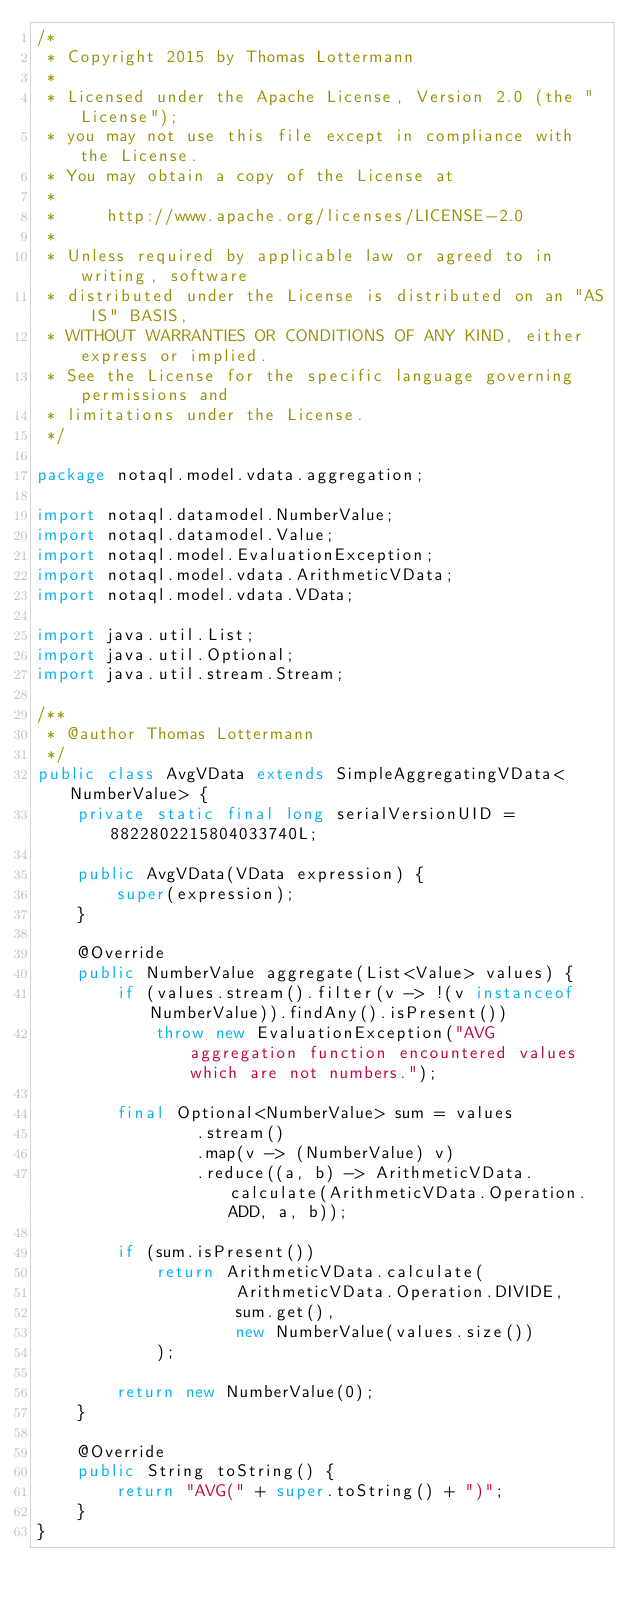<code> <loc_0><loc_0><loc_500><loc_500><_Java_>/*
 * Copyright 2015 by Thomas Lottermann
 *
 * Licensed under the Apache License, Version 2.0 (the "License");
 * you may not use this file except in compliance with the License.
 * You may obtain a copy of the License at
 *
 *     http://www.apache.org/licenses/LICENSE-2.0
 *
 * Unless required by applicable law or agreed to in writing, software
 * distributed under the License is distributed on an "AS IS" BASIS,
 * WITHOUT WARRANTIES OR CONDITIONS OF ANY KIND, either express or implied.
 * See the License for the specific language governing permissions and
 * limitations under the License.
 */

package notaql.model.vdata.aggregation;

import notaql.datamodel.NumberValue;
import notaql.datamodel.Value;
import notaql.model.EvaluationException;
import notaql.model.vdata.ArithmeticVData;
import notaql.model.vdata.VData;

import java.util.List;
import java.util.Optional;
import java.util.stream.Stream;

/**
 * @author Thomas Lottermann
 */
public class AvgVData extends SimpleAggregatingVData<NumberValue> {
    private static final long serialVersionUID = 8822802215804033740L;

    public AvgVData(VData expression) {
        super(expression);
    }

    @Override
    public NumberValue aggregate(List<Value> values) {
        if (values.stream().filter(v -> !(v instanceof NumberValue)).findAny().isPresent())
            throw new EvaluationException("AVG aggregation function encountered values which are not numbers.");

        final Optional<NumberValue> sum = values
                .stream()
                .map(v -> (NumberValue) v)
                .reduce((a, b) -> ArithmeticVData.calculate(ArithmeticVData.Operation.ADD, a, b));

        if (sum.isPresent())
            return ArithmeticVData.calculate(
                    ArithmeticVData.Operation.DIVIDE,
                    sum.get(),
                    new NumberValue(values.size())
            );

        return new NumberValue(0);
    }

    @Override
    public String toString() {
        return "AVG(" + super.toString() + ")";
    }
}
</code> 